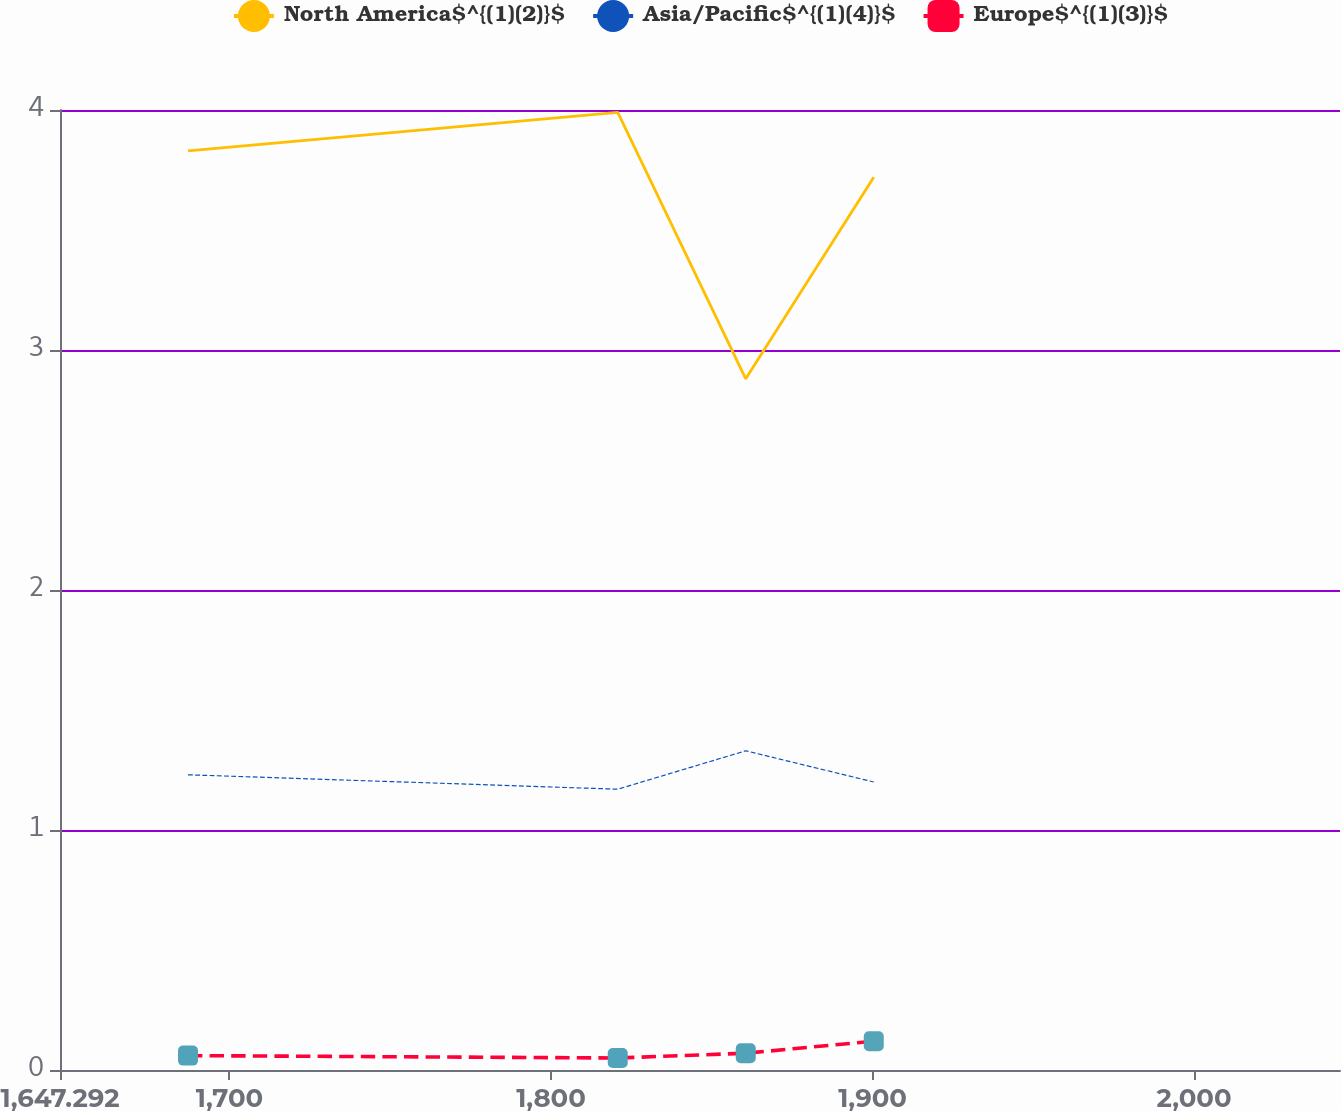Convert chart to OTSL. <chart><loc_0><loc_0><loc_500><loc_500><line_chart><ecel><fcel>North America$^{(1)(2)}$<fcel>Asia/Pacific$^{(1)(4)}$<fcel>Europe$^{(1)(3)}$<nl><fcel>1687.1<fcel>3.83<fcel>1.23<fcel>0.06<nl><fcel>1820.75<fcel>3.99<fcel>1.17<fcel>0.05<nl><fcel>1860.56<fcel>2.88<fcel>1.33<fcel>0.07<nl><fcel>1900.37<fcel>3.72<fcel>1.2<fcel>0.12<nl><fcel>2085.18<fcel>3.01<fcel>1<fcel>0.13<nl></chart> 